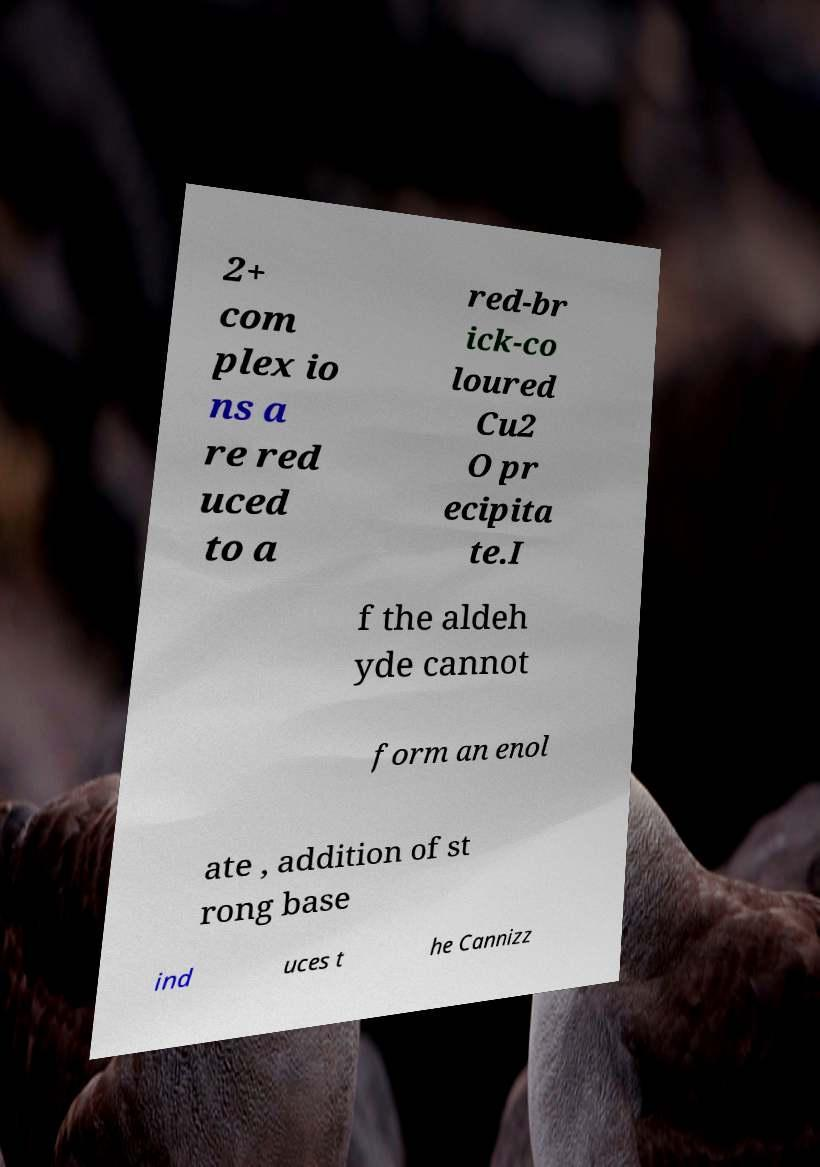For documentation purposes, I need the text within this image transcribed. Could you provide that? 2+ com plex io ns a re red uced to a red-br ick-co loured Cu2 O pr ecipita te.I f the aldeh yde cannot form an enol ate , addition of st rong base ind uces t he Cannizz 